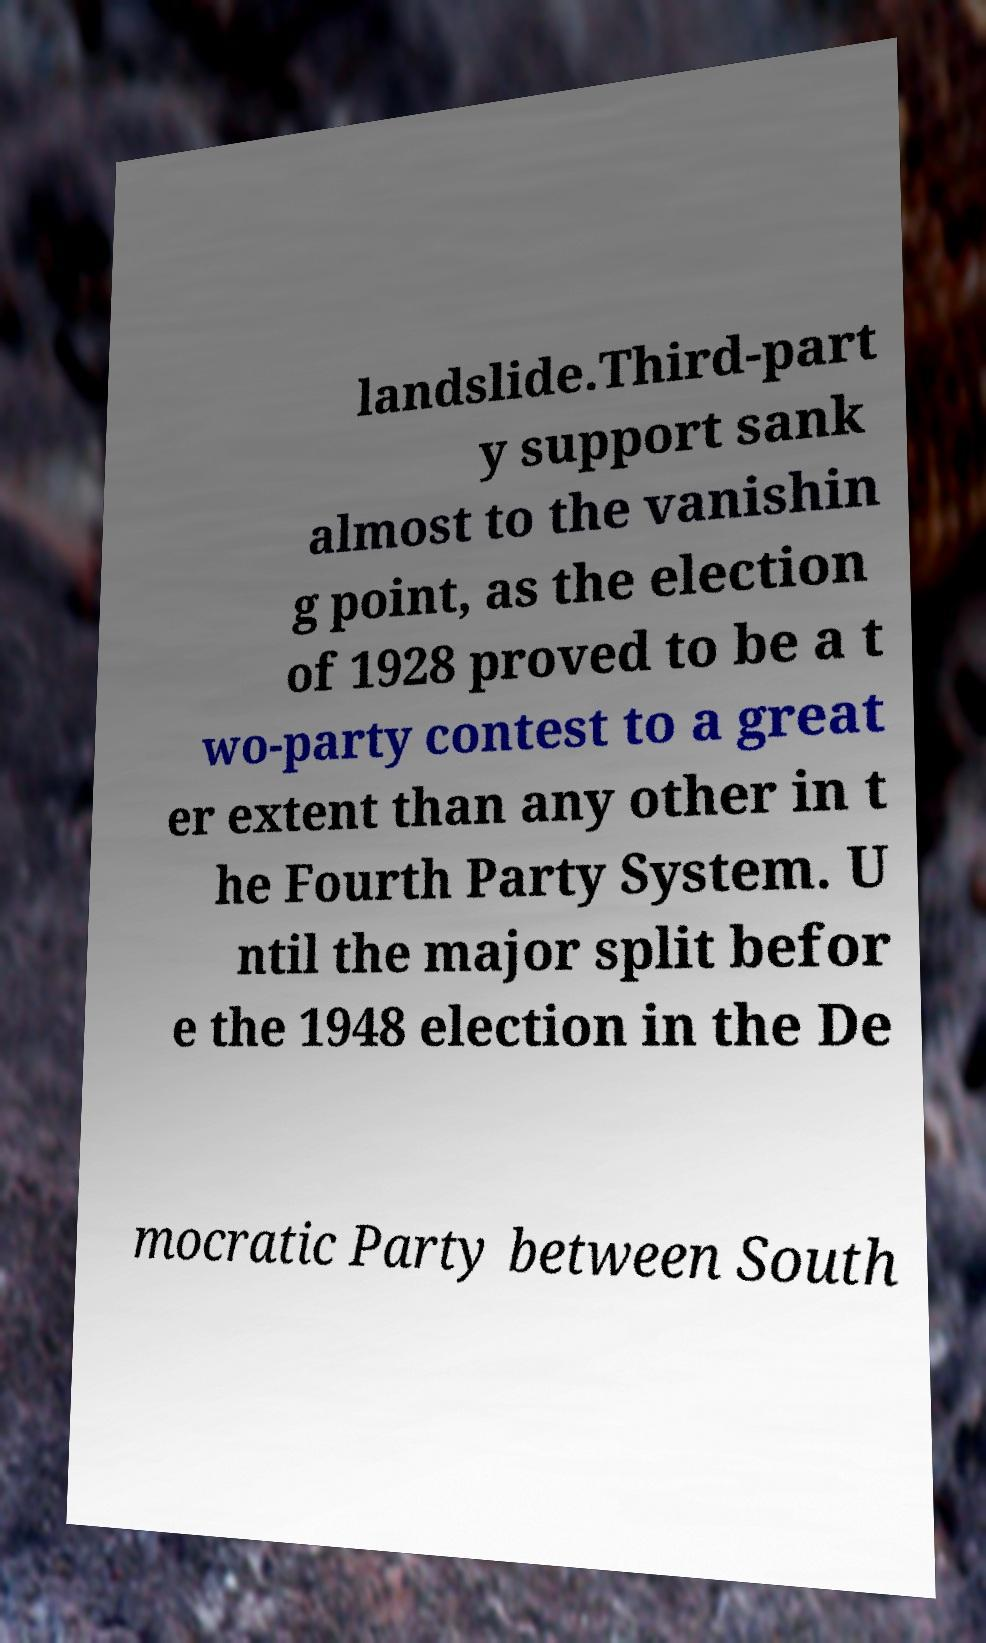I need the written content from this picture converted into text. Can you do that? landslide.Third-part y support sank almost to the vanishin g point, as the election of 1928 proved to be a t wo-party contest to a great er extent than any other in t he Fourth Party System. U ntil the major split befor e the 1948 election in the De mocratic Party between South 